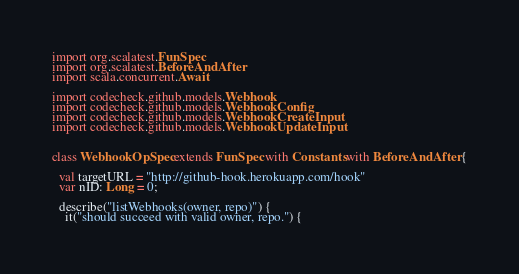Convert code to text. <code><loc_0><loc_0><loc_500><loc_500><_Scala_>
import org.scalatest.FunSpec
import org.scalatest.BeforeAndAfter
import scala.concurrent.Await

import codecheck.github.models.Webhook
import codecheck.github.models.WebhookConfig
import codecheck.github.models.WebhookCreateInput
import codecheck.github.models.WebhookUpdateInput


class WebhookOpSpec extends FunSpec with Constants with BeforeAndAfter {

  val targetURL = "http://github-hook.herokuapp.com/hook"
  var nID: Long = 0;

  describe("listWebhooks(owner, repo)") {
    it("should succeed with valid owner, repo.") {</code> 